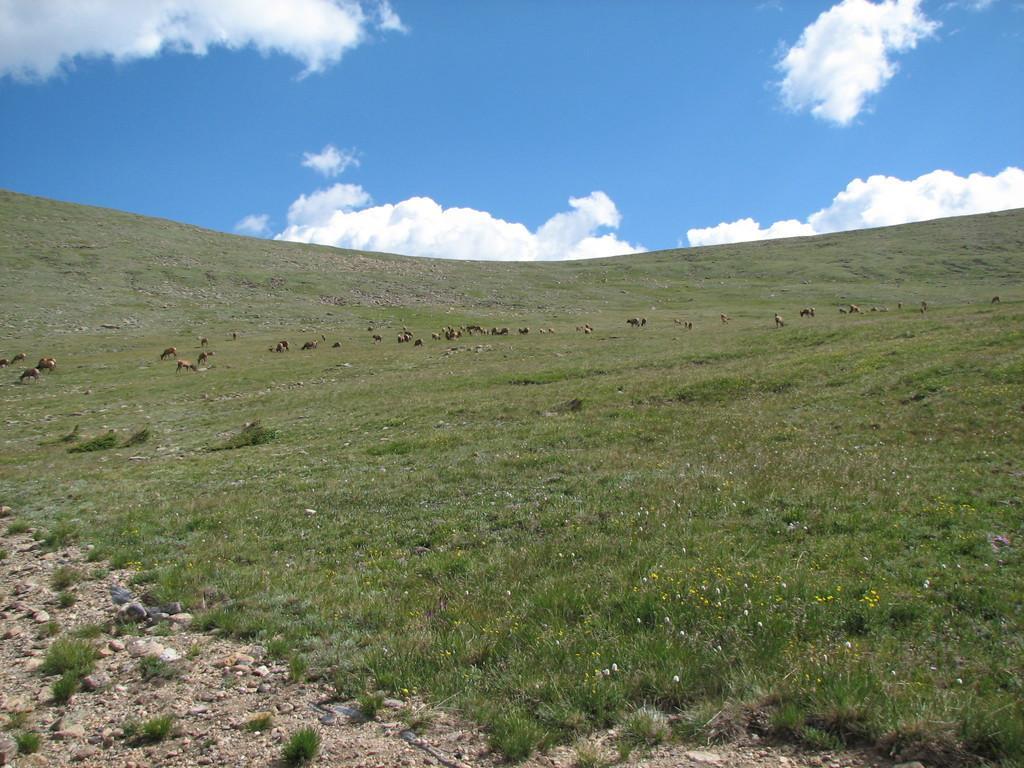Could you give a brief overview of what you see in this image? In the image there is grass on the ground. And also there are small flowers and few animals. At the top of the image there is sky with clouds. 